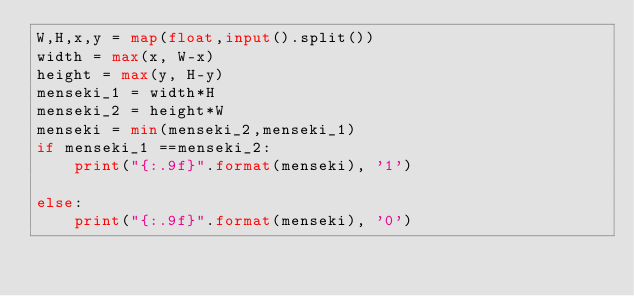<code> <loc_0><loc_0><loc_500><loc_500><_Python_>W,H,x,y = map(float,input().split())
width = max(x, W-x)
height = max(y, H-y)
menseki_1 = width*H
menseki_2 = height*W
menseki = min(menseki_2,menseki_1)
if menseki_1 ==menseki_2:
    print("{:.9f}".format(menseki), '1')
    
else:
    print("{:.9f}".format(menseki), '0')
</code> 